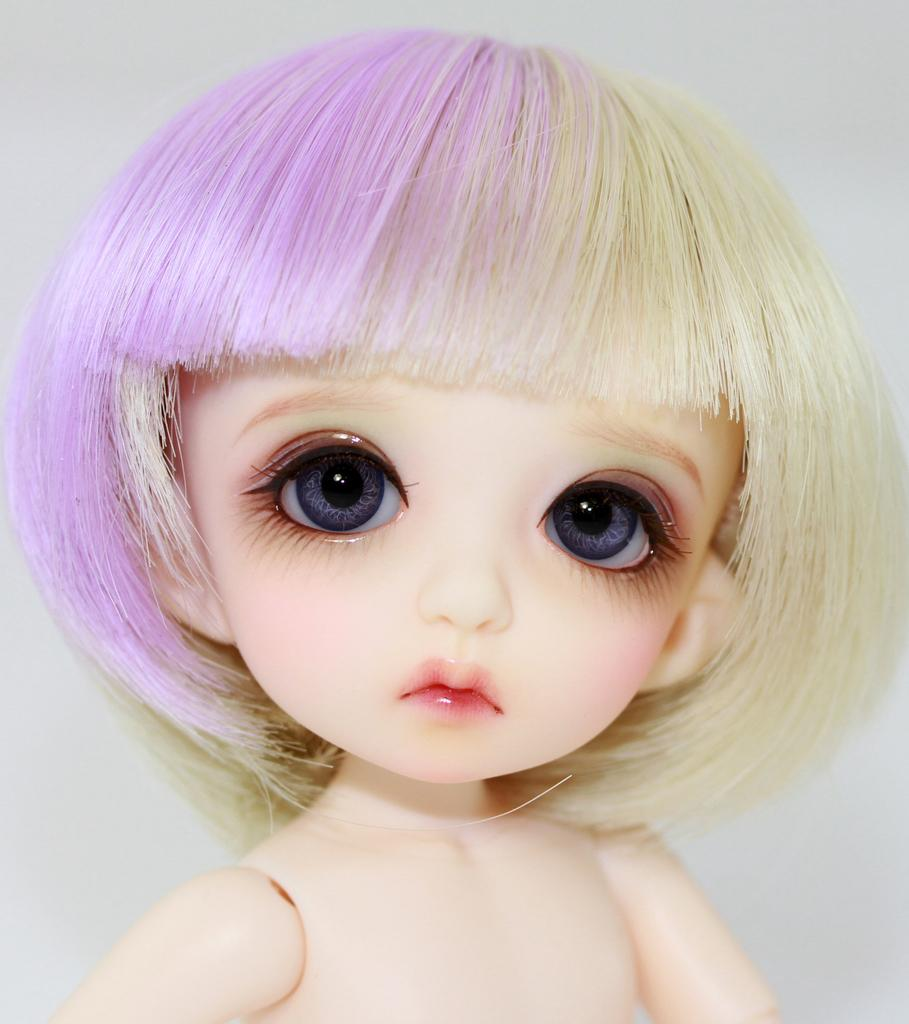What object in the picture can be identified as a toy? There is a toy present in the picture. What type of attraction can be seen in the background of the image? There is no attraction present in the image; it only features a toy. What type of acoustics can be heard coming from the toy in the image? There is no sound or acoustics associated with the toy in the image, as it is a still picture. 